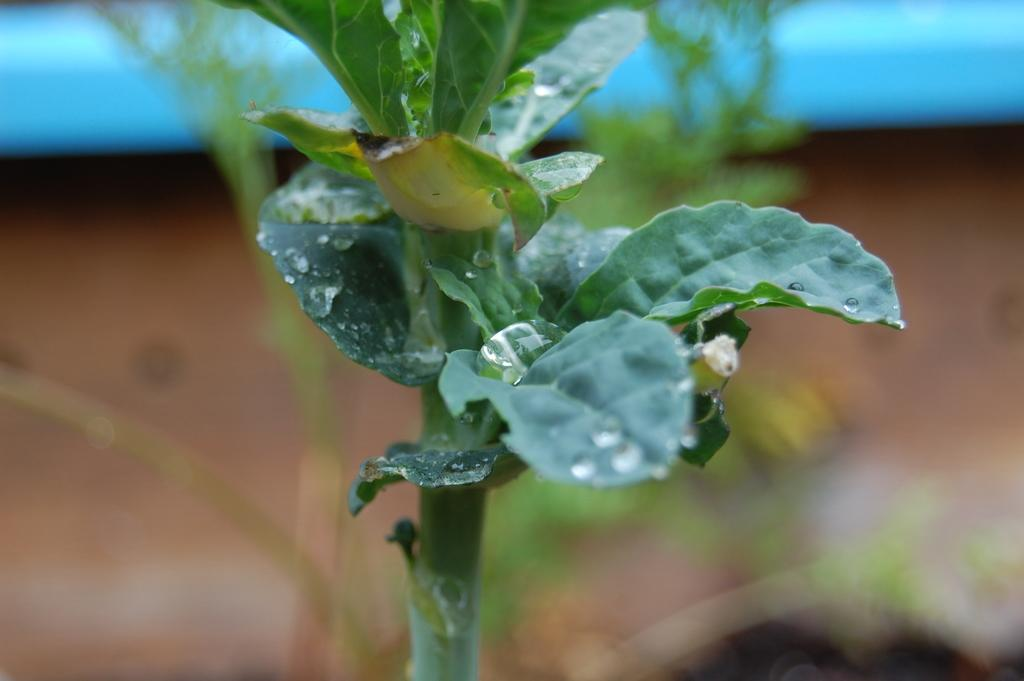What is present in the image? There is a plant in the image. Can you describe the background of the image? The background of the image is blurred. How many rings are visible on the plant's stem in the image? There are no rings visible on the plant's stem in the image, as the focus is on the plant itself and not its stem. 